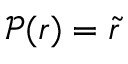<formula> <loc_0><loc_0><loc_500><loc_500>\mathcal { P } ( r ) = \tilde { r }</formula> 